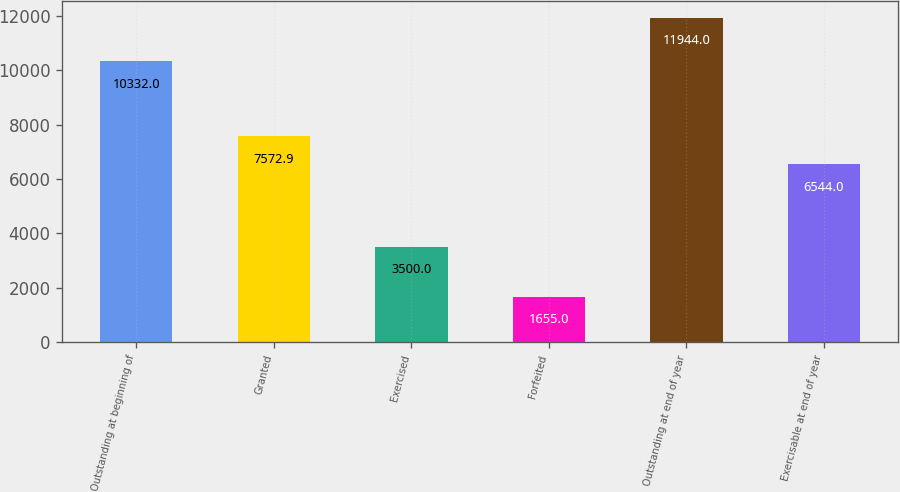Convert chart to OTSL. <chart><loc_0><loc_0><loc_500><loc_500><bar_chart><fcel>Outstanding at beginning of<fcel>Granted<fcel>Exercised<fcel>Forfeited<fcel>Outstanding at end of year<fcel>Exercisable at end of year<nl><fcel>10332<fcel>7572.9<fcel>3500<fcel>1655<fcel>11944<fcel>6544<nl></chart> 